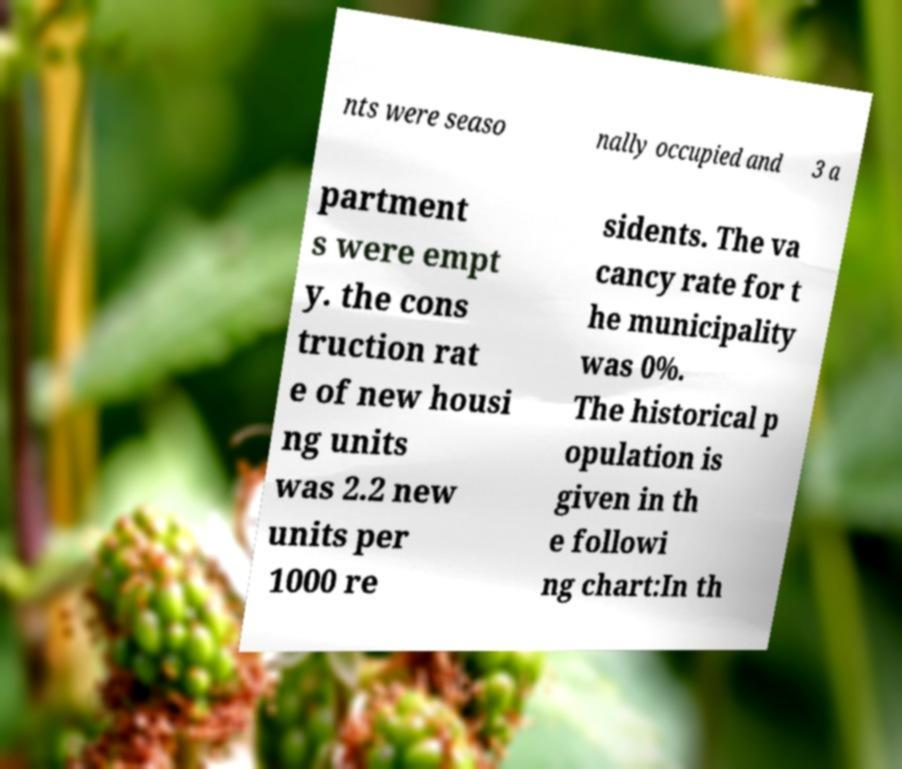Could you assist in decoding the text presented in this image and type it out clearly? nts were seaso nally occupied and 3 a partment s were empt y. the cons truction rat e of new housi ng units was 2.2 new units per 1000 re sidents. The va cancy rate for t he municipality was 0%. The historical p opulation is given in th e followi ng chart:In th 